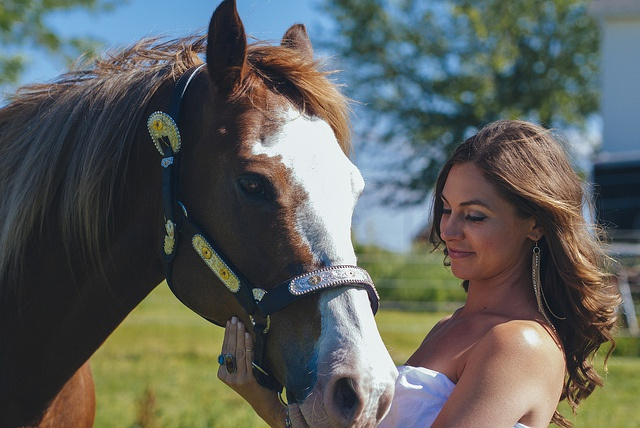Describe the objects in this image and their specific colors. I can see horse in gray, black, lightgray, and darkgray tones and people in gray, black, brown, and maroon tones in this image. 